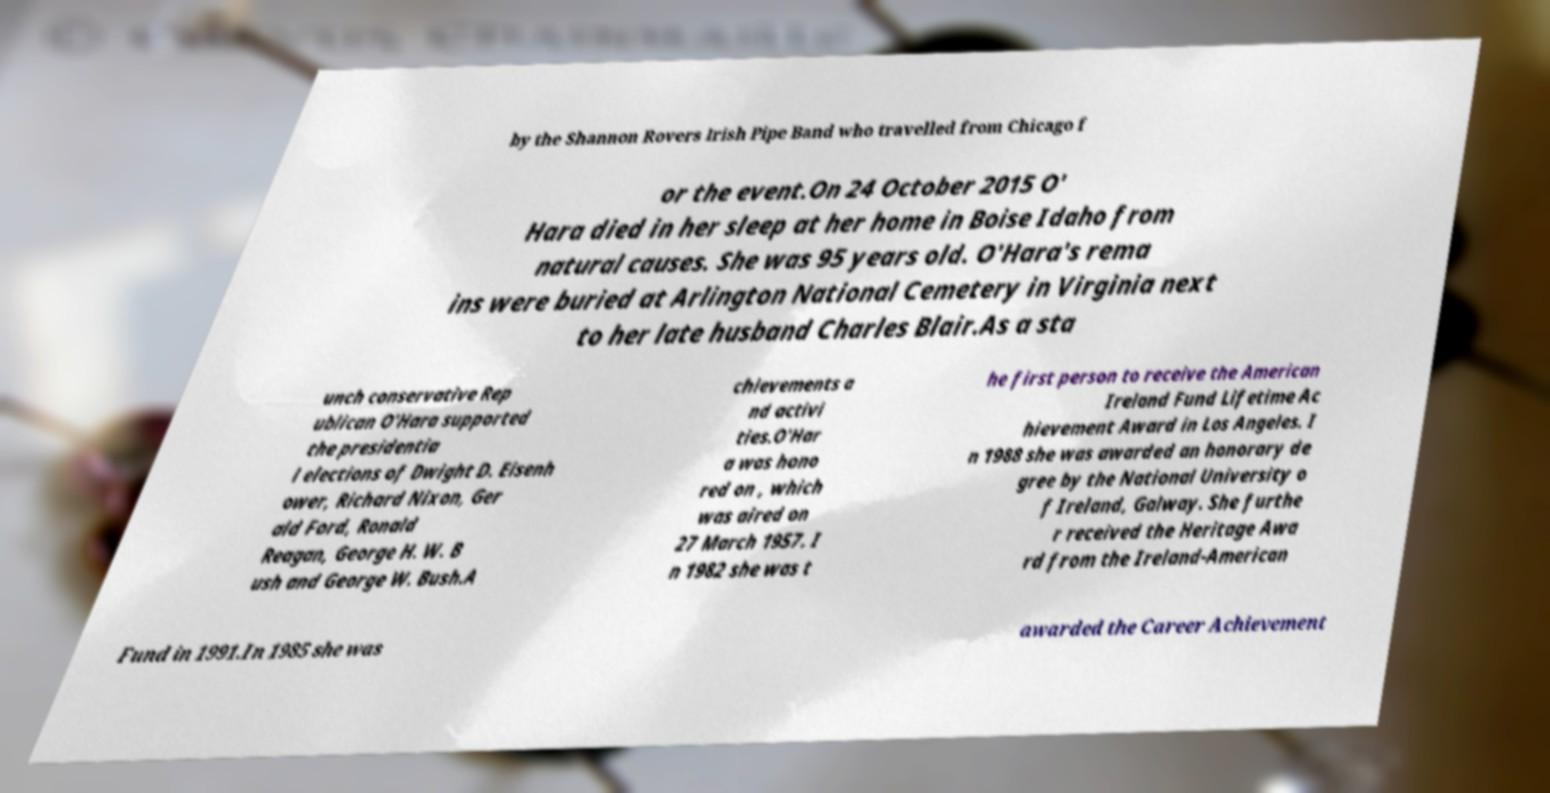Could you assist in decoding the text presented in this image and type it out clearly? by the Shannon Rovers Irish Pipe Band who travelled from Chicago f or the event.On 24 October 2015 O' Hara died in her sleep at her home in Boise Idaho from natural causes. She was 95 years old. O'Hara's rema ins were buried at Arlington National Cemetery in Virginia next to her late husband Charles Blair.As a sta unch conservative Rep ublican O'Hara supported the presidentia l elections of Dwight D. Eisenh ower, Richard Nixon, Ger ald Ford, Ronald Reagan, George H. W. B ush and George W. Bush.A chievements a nd activi ties.O'Har a was hono red on , which was aired on 27 March 1957. I n 1982 she was t he first person to receive the American Ireland Fund Lifetime Ac hievement Award in Los Angeles. I n 1988 she was awarded an honorary de gree by the National University o f Ireland, Galway. She furthe r received the Heritage Awa rd from the Ireland-American Fund in 1991.In 1985 she was awarded the Career Achievement 